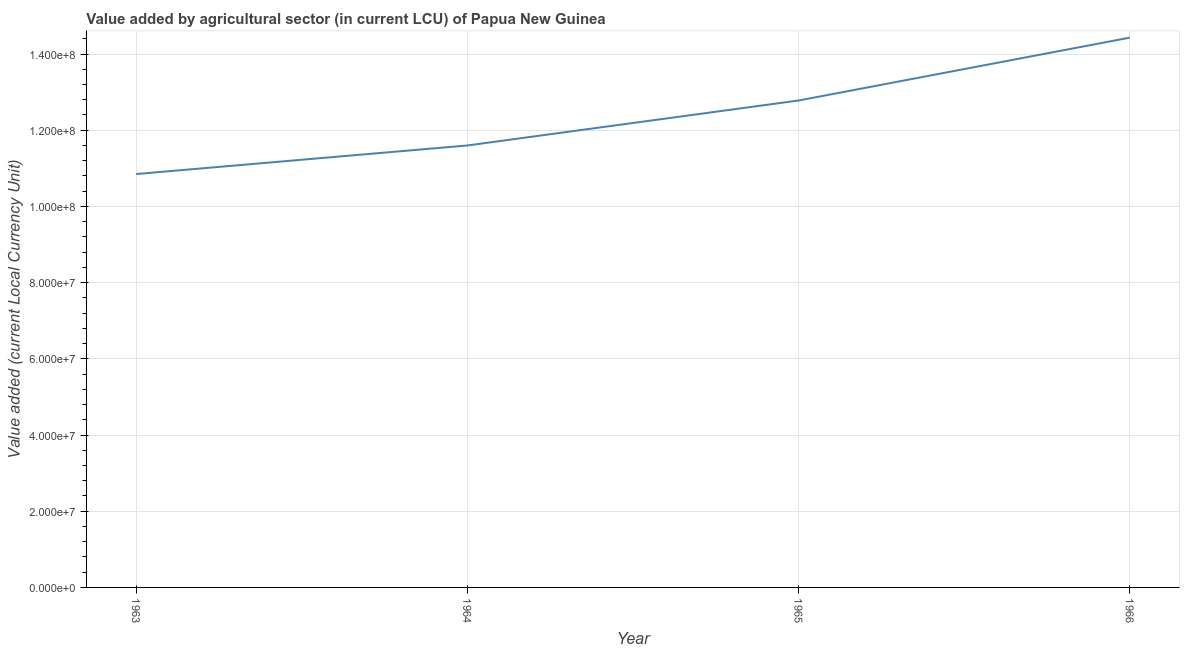What is the value added by agriculture sector in 1965?
Give a very brief answer. 1.28e+08. Across all years, what is the maximum value added by agriculture sector?
Provide a succinct answer. 1.44e+08. Across all years, what is the minimum value added by agriculture sector?
Provide a short and direct response. 1.08e+08. In which year was the value added by agriculture sector maximum?
Offer a terse response. 1966. What is the sum of the value added by agriculture sector?
Your answer should be very brief. 4.97e+08. What is the difference between the value added by agriculture sector in 1963 and 1964?
Your answer should be compact. -7.50e+06. What is the average value added by agriculture sector per year?
Give a very brief answer. 1.24e+08. What is the median value added by agriculture sector?
Make the answer very short. 1.22e+08. In how many years, is the value added by agriculture sector greater than 20000000 LCU?
Provide a succinct answer. 4. Do a majority of the years between 1964 and 1965 (inclusive) have value added by agriculture sector greater than 60000000 LCU?
Offer a terse response. Yes. What is the ratio of the value added by agriculture sector in 1963 to that in 1966?
Give a very brief answer. 0.75. Is the value added by agriculture sector in 1965 less than that in 1966?
Provide a short and direct response. Yes. Is the difference between the value added by agriculture sector in 1963 and 1964 greater than the difference between any two years?
Your answer should be very brief. No. What is the difference between the highest and the second highest value added by agriculture sector?
Ensure brevity in your answer.  1.65e+07. Is the sum of the value added by agriculture sector in 1964 and 1965 greater than the maximum value added by agriculture sector across all years?
Offer a very short reply. Yes. What is the difference between the highest and the lowest value added by agriculture sector?
Your answer should be compact. 3.58e+07. How many lines are there?
Ensure brevity in your answer.  1. Does the graph contain any zero values?
Your answer should be compact. No. Does the graph contain grids?
Give a very brief answer. Yes. What is the title of the graph?
Your answer should be compact. Value added by agricultural sector (in current LCU) of Papua New Guinea. What is the label or title of the X-axis?
Provide a short and direct response. Year. What is the label or title of the Y-axis?
Provide a succinct answer. Value added (current Local Currency Unit). What is the Value added (current Local Currency Unit) in 1963?
Your answer should be compact. 1.08e+08. What is the Value added (current Local Currency Unit) in 1964?
Provide a succinct answer. 1.16e+08. What is the Value added (current Local Currency Unit) of 1965?
Ensure brevity in your answer.  1.28e+08. What is the Value added (current Local Currency Unit) of 1966?
Provide a succinct answer. 1.44e+08. What is the difference between the Value added (current Local Currency Unit) in 1963 and 1964?
Offer a terse response. -7.50e+06. What is the difference between the Value added (current Local Currency Unit) in 1963 and 1965?
Provide a succinct answer. -1.93e+07. What is the difference between the Value added (current Local Currency Unit) in 1963 and 1966?
Offer a terse response. -3.58e+07. What is the difference between the Value added (current Local Currency Unit) in 1964 and 1965?
Ensure brevity in your answer.  -1.18e+07. What is the difference between the Value added (current Local Currency Unit) in 1964 and 1966?
Your response must be concise. -2.83e+07. What is the difference between the Value added (current Local Currency Unit) in 1965 and 1966?
Your answer should be compact. -1.65e+07. What is the ratio of the Value added (current Local Currency Unit) in 1963 to that in 1964?
Ensure brevity in your answer.  0.94. What is the ratio of the Value added (current Local Currency Unit) in 1963 to that in 1965?
Make the answer very short. 0.85. What is the ratio of the Value added (current Local Currency Unit) in 1963 to that in 1966?
Offer a very short reply. 0.75. What is the ratio of the Value added (current Local Currency Unit) in 1964 to that in 1965?
Offer a terse response. 0.91. What is the ratio of the Value added (current Local Currency Unit) in 1964 to that in 1966?
Offer a very short reply. 0.8. What is the ratio of the Value added (current Local Currency Unit) in 1965 to that in 1966?
Make the answer very short. 0.89. 